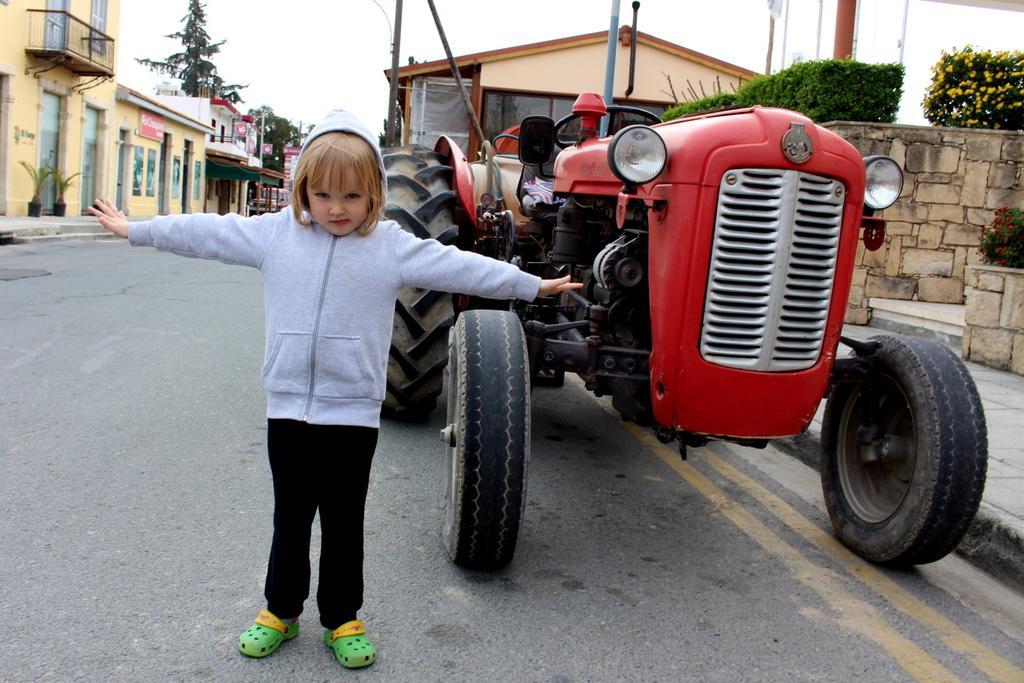Describe this image in one or two sentences. In this image we can see a girl standing on a road, behind the girl there is a tractor, on the left side of the image there are buildings, trees, potted plants, on the right side of the image there are plants and wall and sky in the background. 